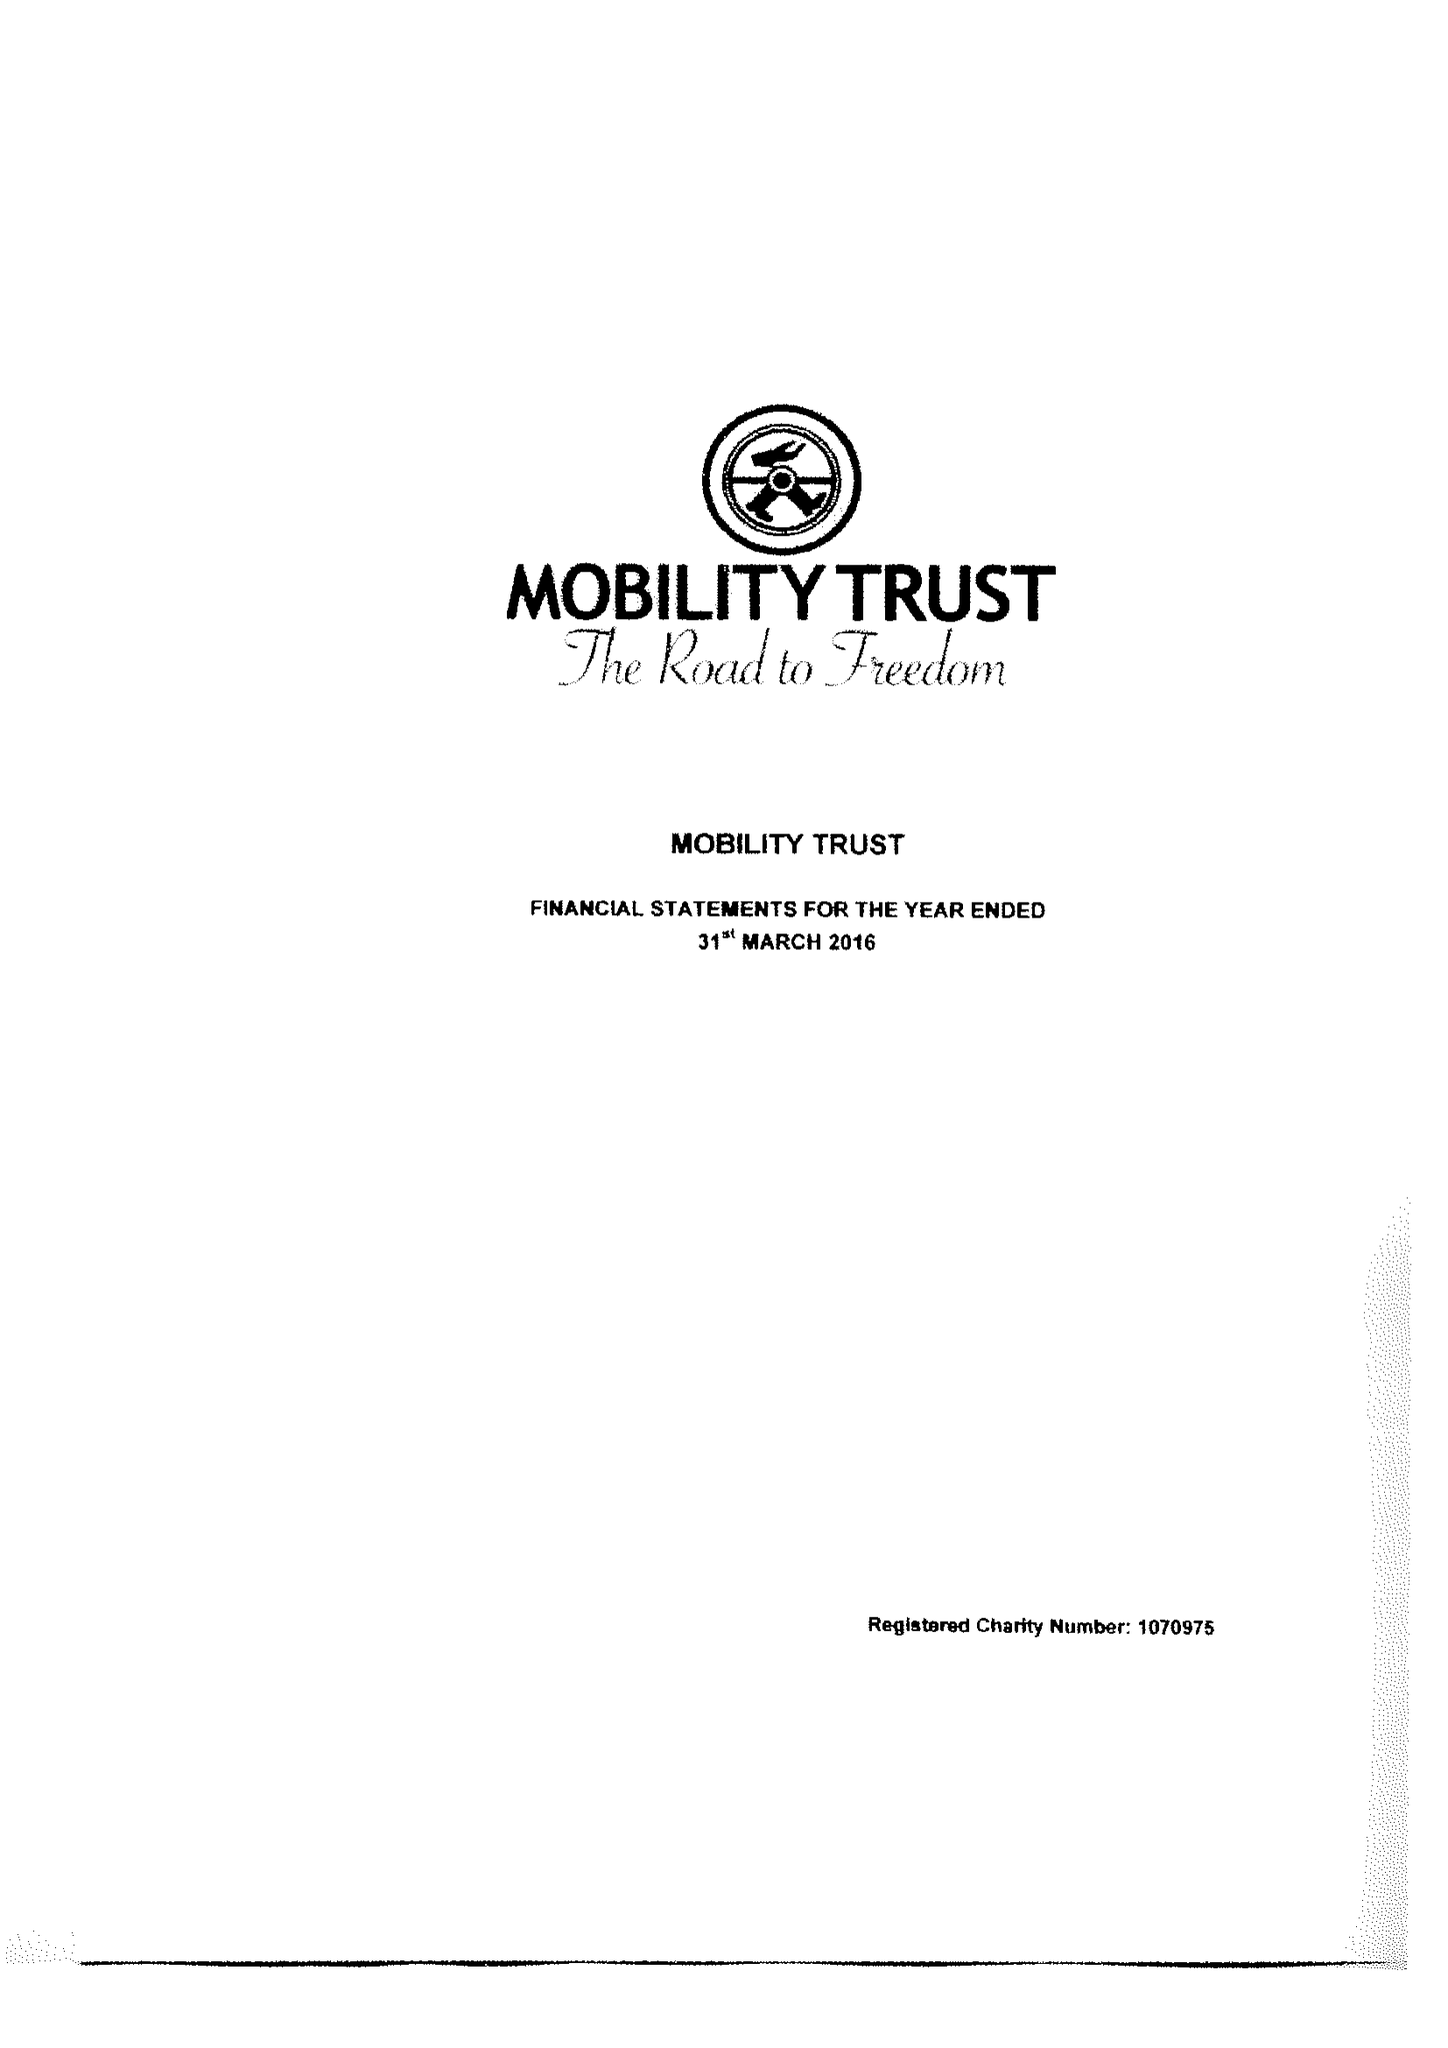What is the value for the income_annually_in_british_pounds?
Answer the question using a single word or phrase. 291070.00 